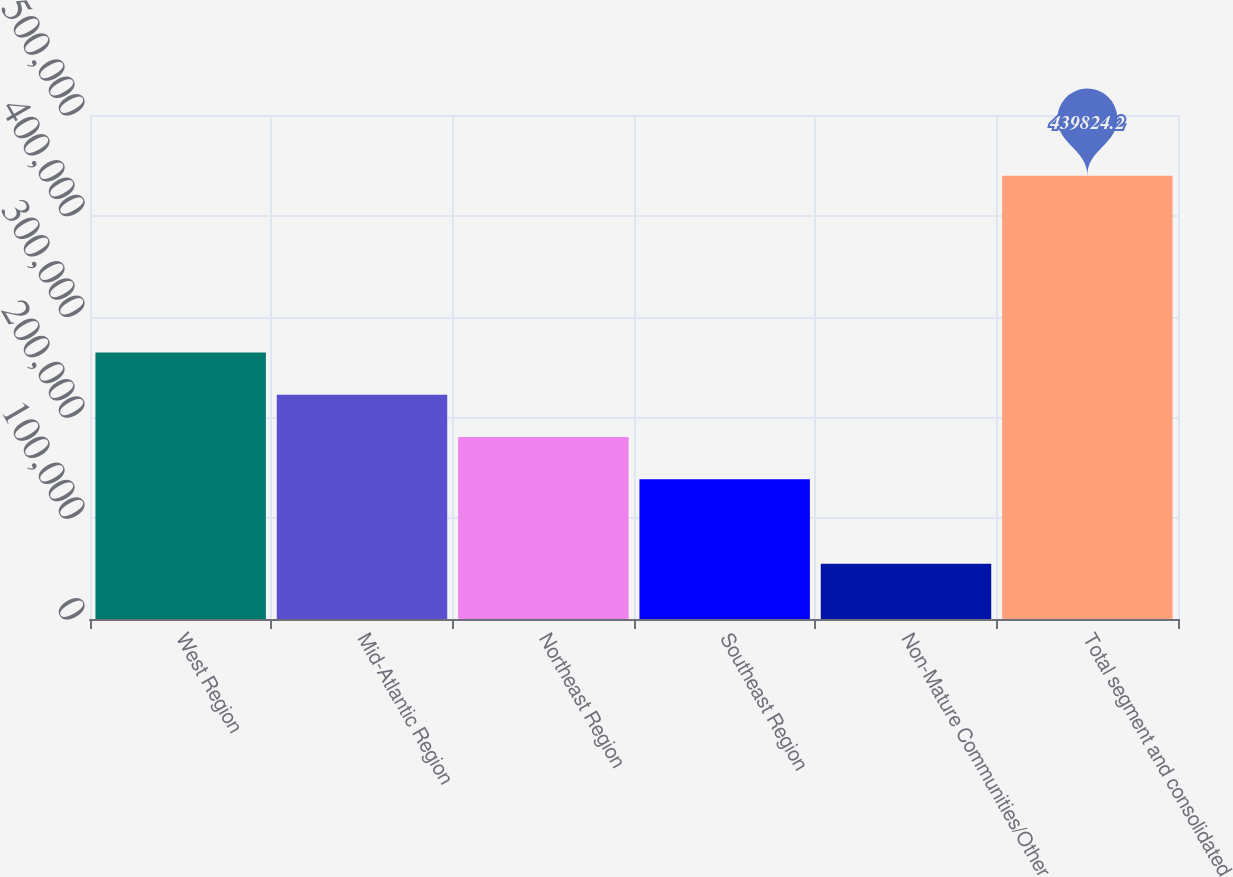Convert chart to OTSL. <chart><loc_0><loc_0><loc_500><loc_500><bar_chart><fcel>West Region<fcel>Mid-Atlantic Region<fcel>Northeast Region<fcel>Southeast Region<fcel>Non-Mature Communities/Other<fcel>Total segment and consolidated<nl><fcel>264367<fcel>222479<fcel>180591<fcel>138703<fcel>54926.2<fcel>439824<nl></chart> 